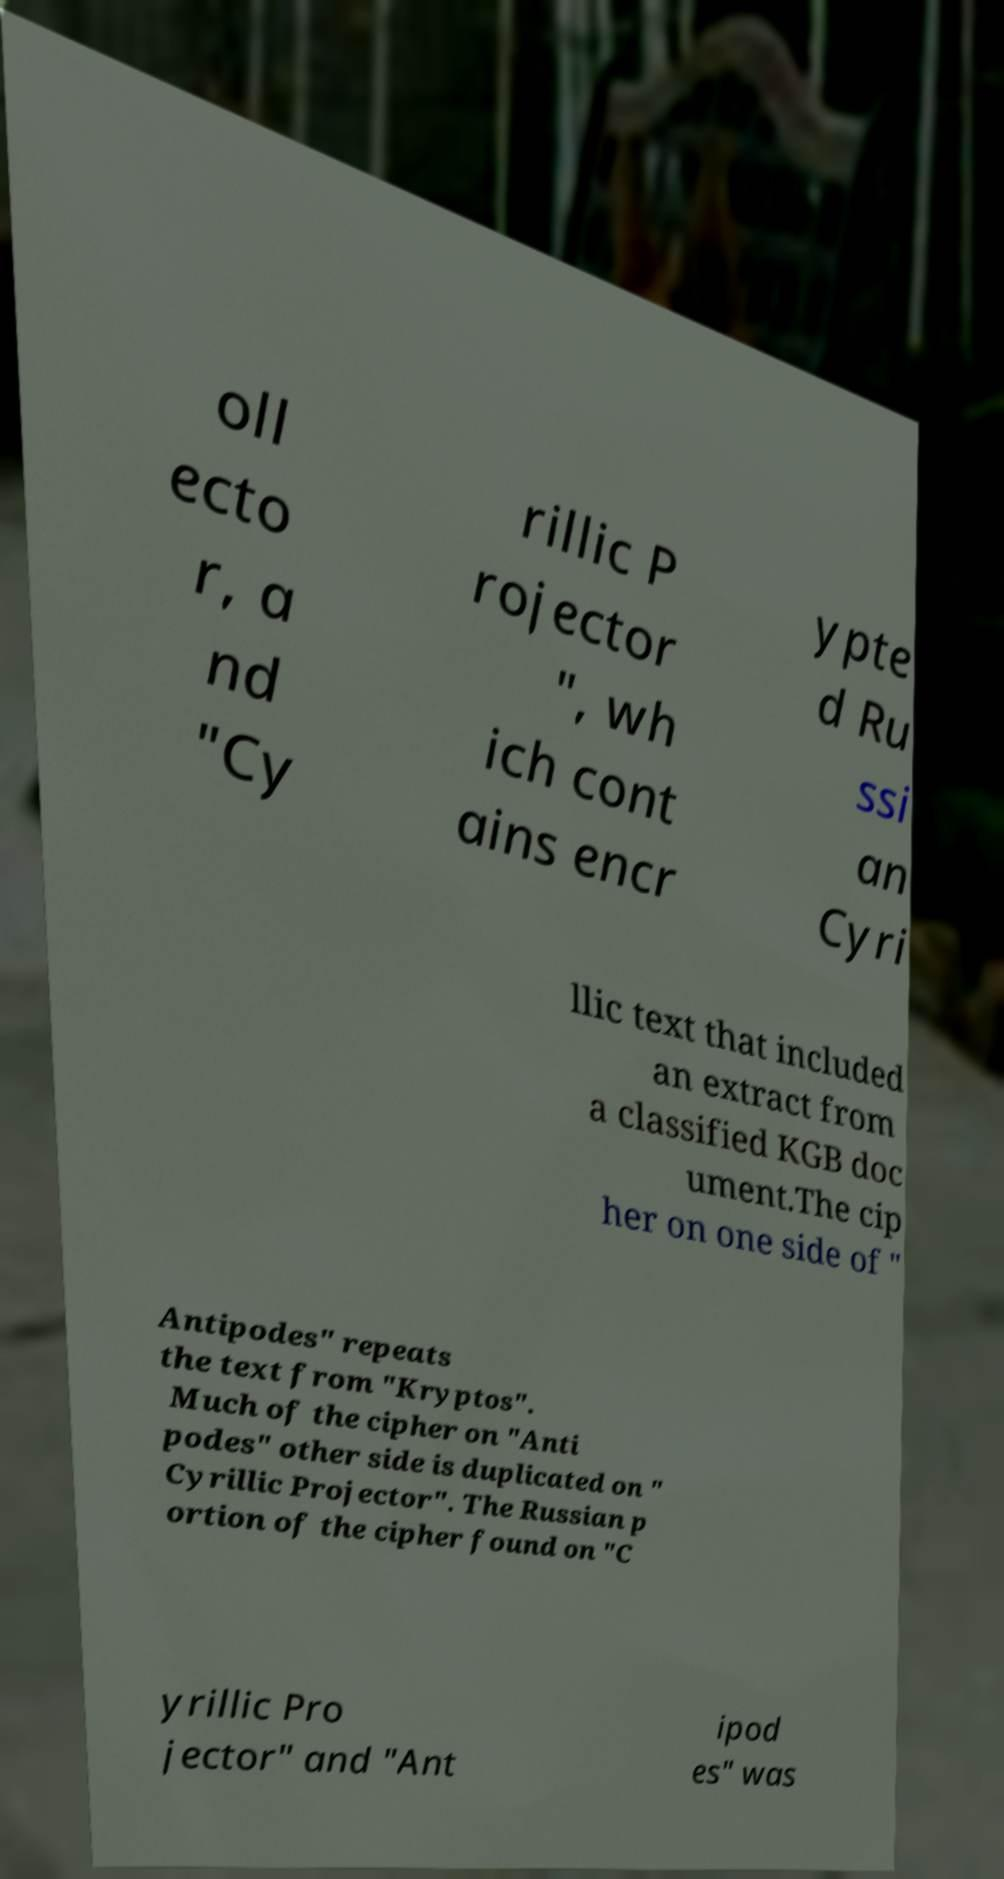Can you accurately transcribe the text from the provided image for me? oll ecto r, a nd "Cy rillic P rojector ", wh ich cont ains encr ypte d Ru ssi an Cyri llic text that included an extract from a classified KGB doc ument.The cip her on one side of " Antipodes" repeats the text from "Kryptos". Much of the cipher on "Anti podes" other side is duplicated on " Cyrillic Projector". The Russian p ortion of the cipher found on "C yrillic Pro jector" and "Ant ipod es" was 